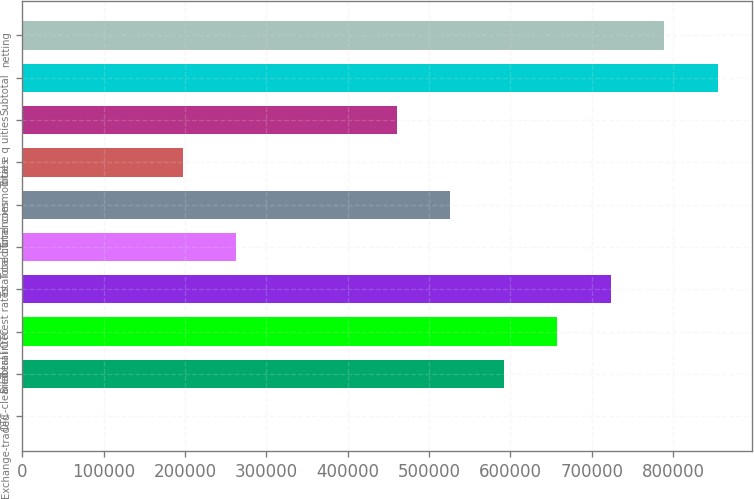Convert chart. <chart><loc_0><loc_0><loc_500><loc_500><bar_chart><fcel>Exchange-traded<fcel>OTC-cleared<fcel>Bilateral OTC<fcel>Total interest rates<fcel>Total credit<fcel>Total currencies<fcel>Total commodities<fcel>Total e q uities<fcel>Subtotal<fcel>netting<nl><fcel>382<fcel>591746<fcel>657453<fcel>723160<fcel>263210<fcel>526039<fcel>197503<fcel>460332<fcel>854574<fcel>788867<nl></chart> 